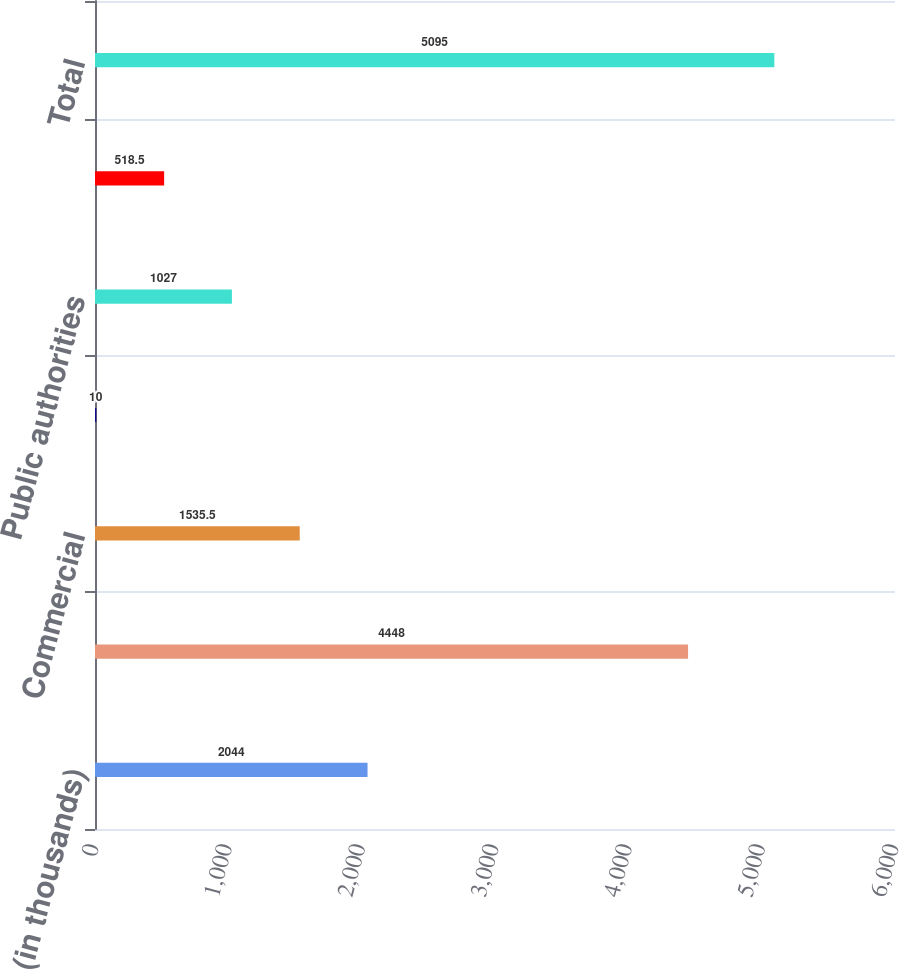<chart> <loc_0><loc_0><loc_500><loc_500><bar_chart><fcel>(in thousands)<fcel>Residential<fcel>Commercial<fcel>Industrial<fcel>Public authorities<fcel>Agricultural and other<fcel>Total<nl><fcel>2044<fcel>4448<fcel>1535.5<fcel>10<fcel>1027<fcel>518.5<fcel>5095<nl></chart> 